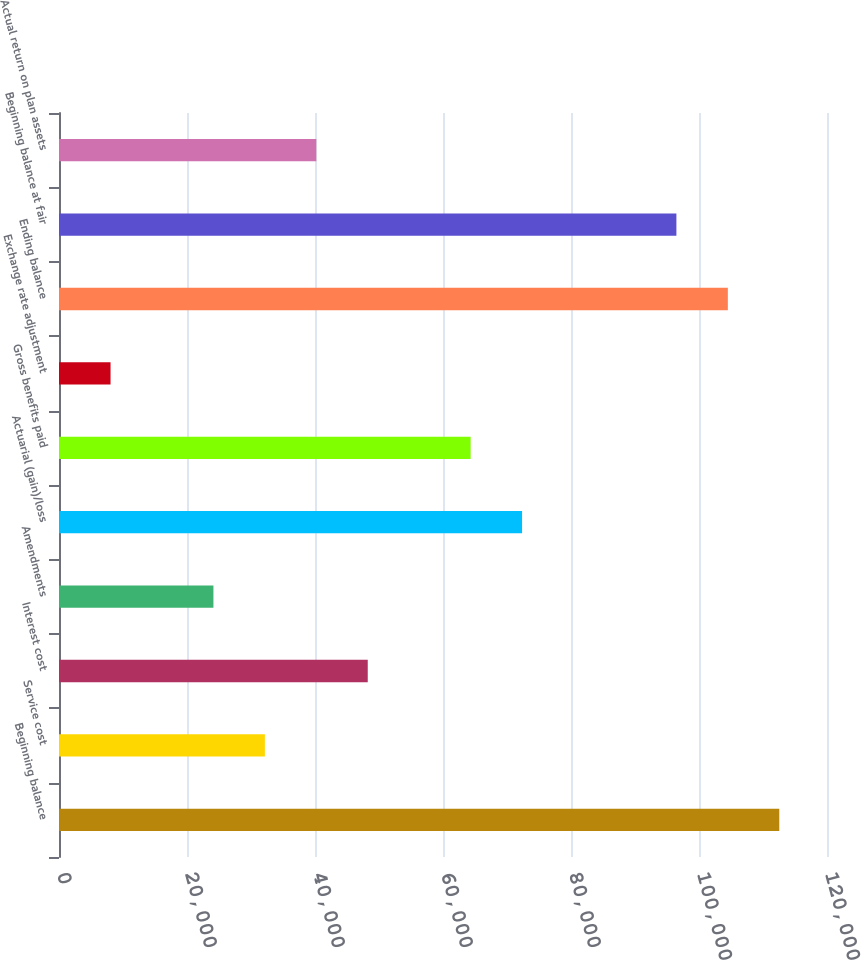Convert chart to OTSL. <chart><loc_0><loc_0><loc_500><loc_500><bar_chart><fcel>Beginning balance<fcel>Service cost<fcel>Interest cost<fcel>Amendments<fcel>Actuarial (gain)/loss<fcel>Gross benefits paid<fcel>Exchange rate adjustment<fcel>Ending balance<fcel>Beginning balance at fair<fcel>Actual return on plan assets<nl><fcel>112544<fcel>32166.8<fcel>48242.2<fcel>24129.1<fcel>72355.3<fcel>64317.6<fcel>8053.7<fcel>104506<fcel>96468.4<fcel>40204.5<nl></chart> 